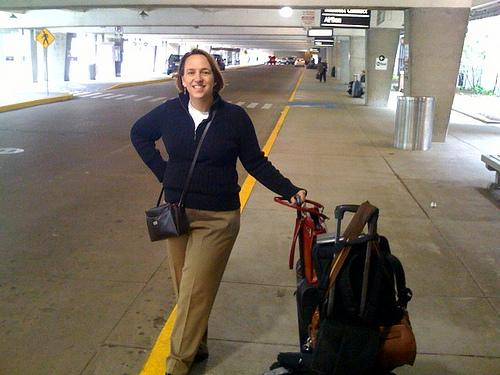What is she doing?

Choices:
A) stealing luggage
B) returning luggage
C) posing
D) exercising posing 